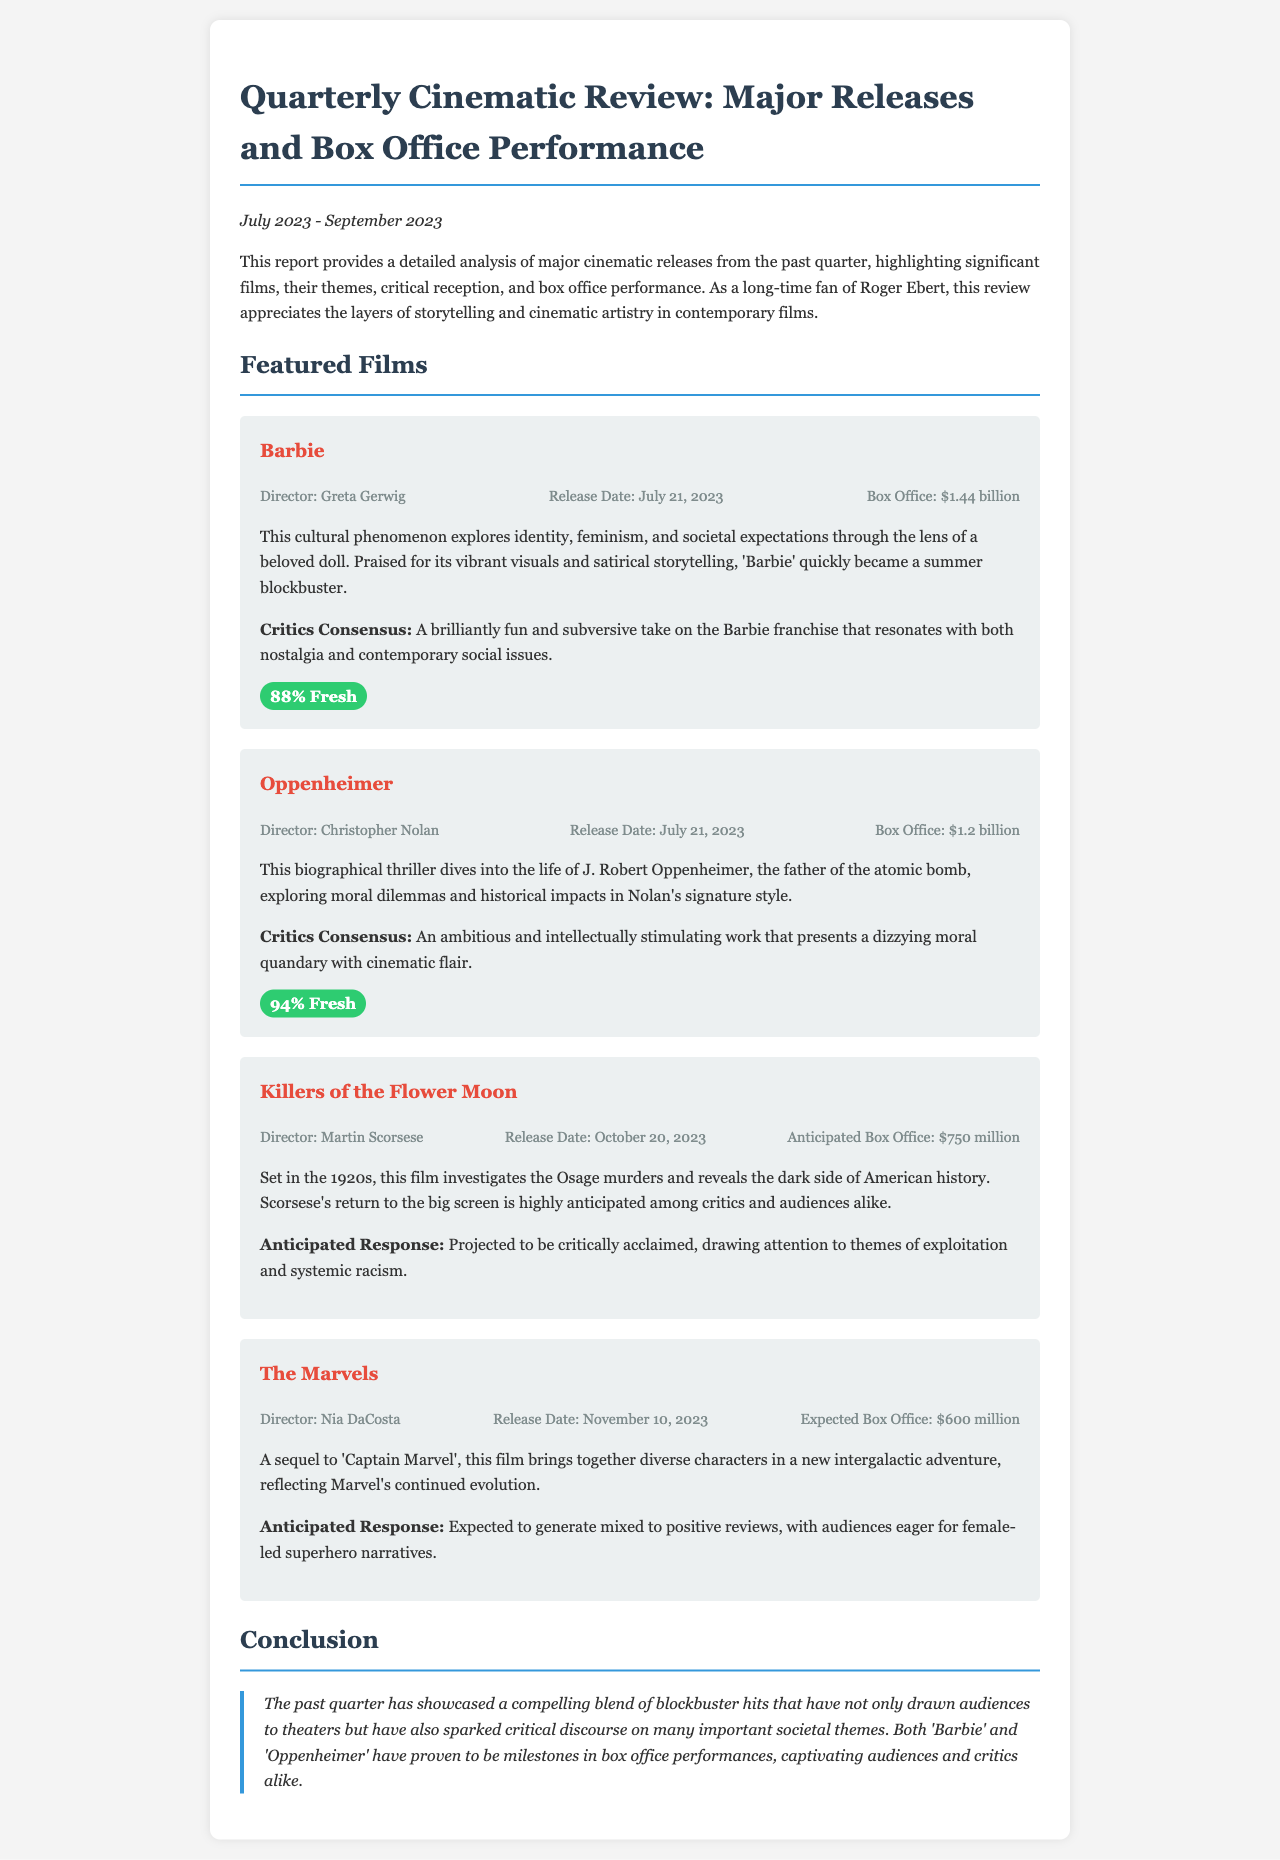What is the release date of Barbie? The release date of Barbie is explicitly mentioned in the document.
Answer: July 21, 2023 What is the box office gross for Oppenheimer? The document provides a specific box office figure for Oppenheimer.
Answer: $1.2 billion Who directed Killers of the Flower Moon? The director's name for Killers of the Flower Moon is stated in the document.
Answer: Martin Scorsese What percentage of critics rated Barbie as fresh? The critics consensus in the document specifies the rating for Barbie.
Answer: 88% Fresh What theme does Barbie explore? The film's themes are explicitly summarized in the document.
Answer: Identity, feminism, and societal expectations Which film is anticipated to have a box office of $600 million? The document mentions the expected box office figures for upcoming films.
Answer: The Marvels What is the anticipated release date of The Marvels? The anticipated release date is given in the film information section of the document.
Answer: November 10, 2023 What is the concluding statement about the films in this quarter? The conclusion reflects on the overall impact of the films released.
Answer: Captivating audiences and critics alike 